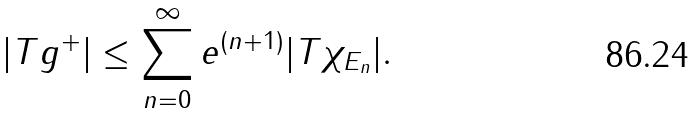<formula> <loc_0><loc_0><loc_500><loc_500>| T g ^ { + } | \leq \sum _ { n = 0 } ^ { \infty } e ^ { ( n + 1 ) } | T \chi _ { E _ { n } } | .</formula> 